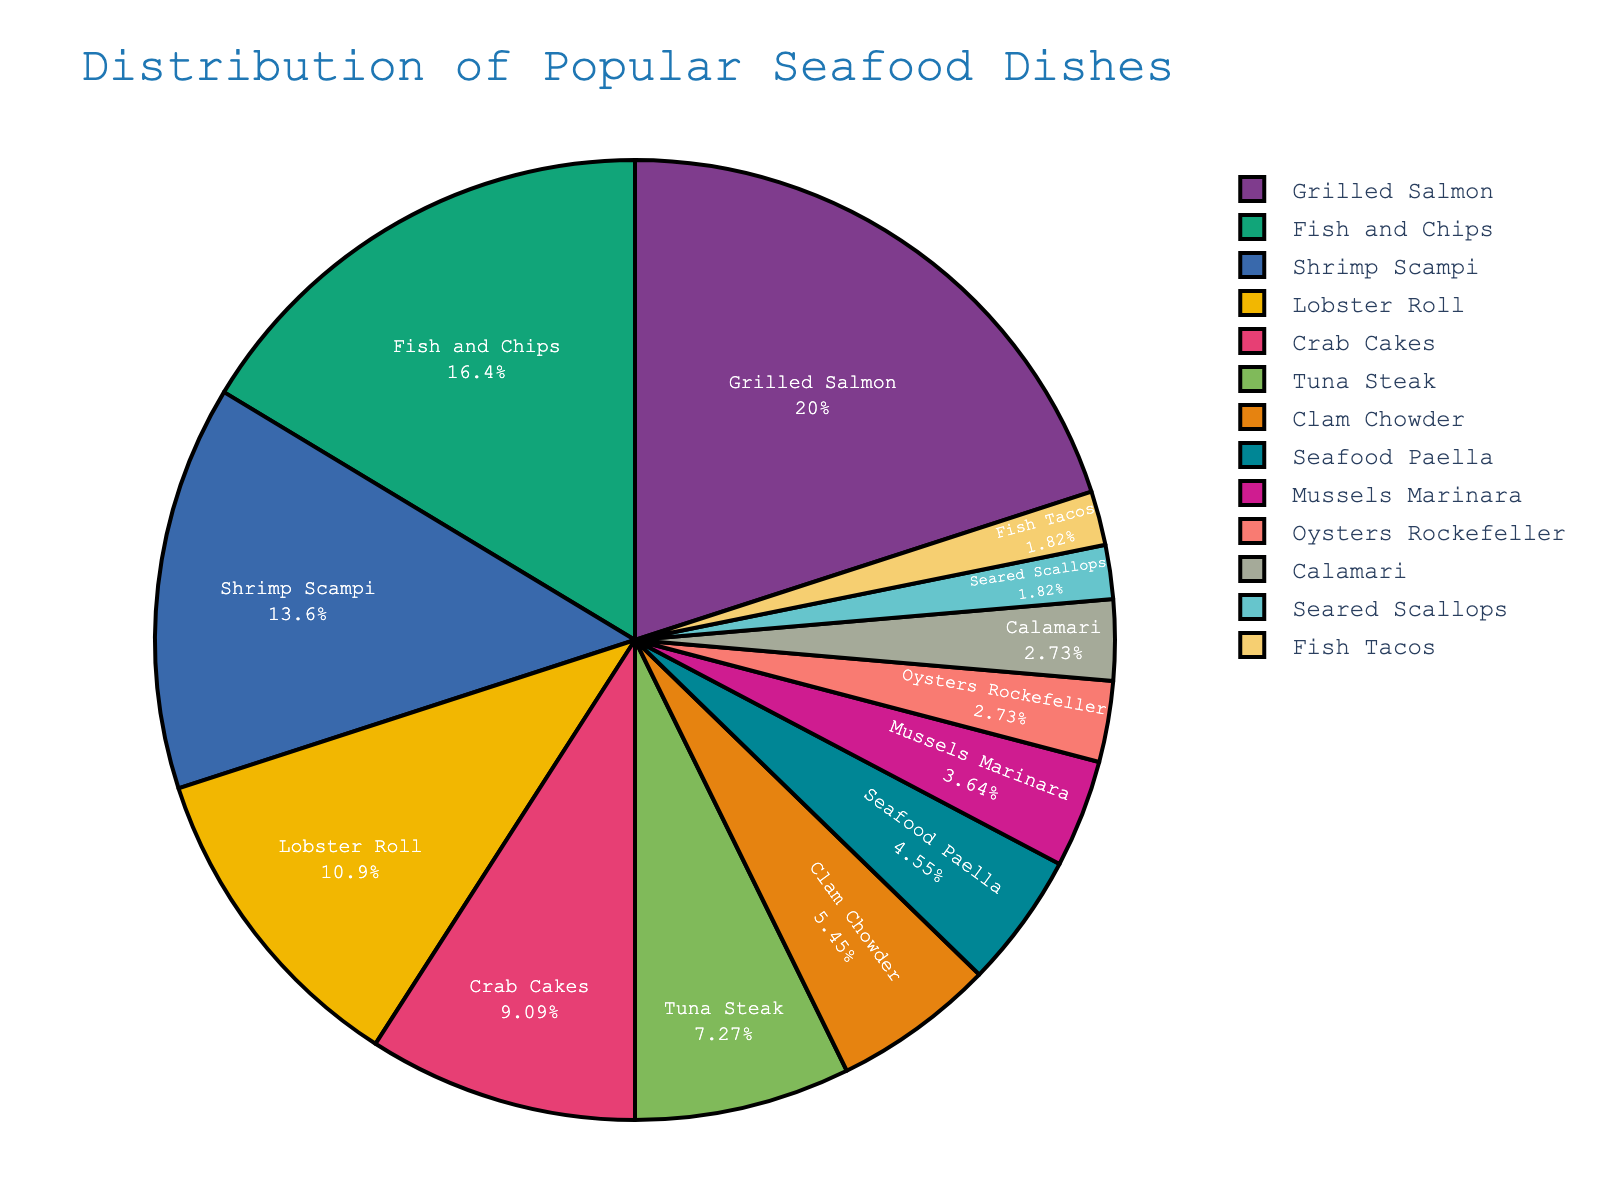Which dish is the most popular? By looking at the figure, the dish with the largest portion represents the most popular dish.
Answer: Grilled Salmon Which dish has a higher percentage: Shrimp Scampi or Crab Cakes? By comparing the size of the slices, Shrimp Scampi has a larger portion than Crab Cakes.
Answer: Shrimp Scampi What's the combined percentage of Oysters Rockefeller and Calamari? Summing the percentages of Oysters Rockefeller (3%) and Calamari (3%) yields 6%.
Answer: 6% Which dishes occupy less than 5% of the chart individually? By identifying slices smaller than 5%, Mussels Marinara, Oysters Rockefeller, Calamari, Seared Scallops, and Fish Tacos all fit this criterion.
Answer: Mussels Marinara, Oysters Rockefeller, Calamari, Seared Scallops, Fish Tacos What is the difference in percentage between Grilled Salmon and Fish and Chips? Subtract the percentage of Fish and Chips (18%) from Grilled Salmon (22%) to find the difference.
Answer: 4% Which dish has the smallest percentage in the distribution? The smallest portion corresponds to Seared Scallops and Fish Tacos, both at 2%.
Answer: Seared Scallops, Fish Tacos How do Grilled Salmon and Seafood Paella compare in terms of popularity? Grilled Salmon (22%) has a significantly larger portion than Seafood Paella (5%).
Answer: Grilled Salmon is more popular What is the average percentage of dishes that are under 10%? Add the percentages of dishes under 10%: Crab Cakes (10%), Tuna Steak (8%), Clam Chowder (6%), Seafood Paella (5%), Mussels Marinara (4%), Oysters Rockefeller (3%), Calamari (3%), Seared Scallops (2%), and Fish Tacos (2%), totaling to 43%. Divide by the number of those dishes (9) to find the average: 43/9 ≈ 4.78%.
Answer: ≈ 4.78% How does the popularity of Tuna Steak compare to Clam Chowder? Tuna Steak has a larger slice, being 8%, whereas Clam Chowder is 6%.
Answer: Tuna Steak is more popular 